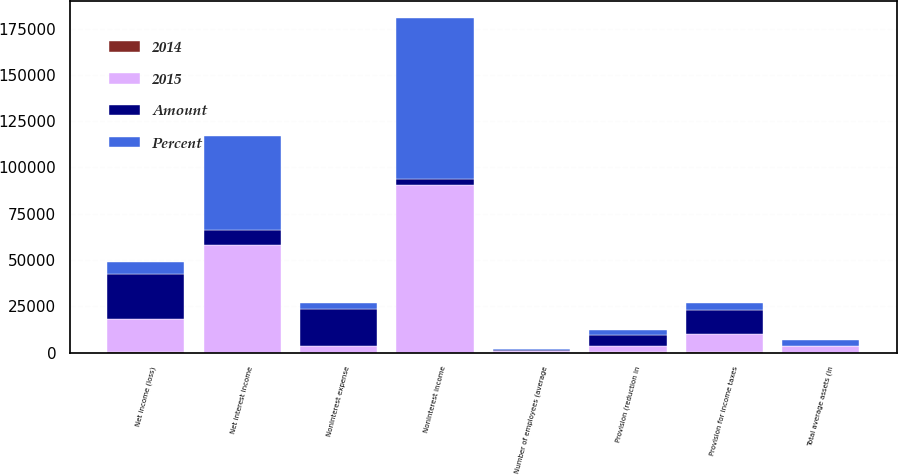Convert chart. <chart><loc_0><loc_0><loc_500><loc_500><stacked_bar_chart><ecel><fcel>Net interest income<fcel>Provision (reduction in<fcel>Noninterest income<fcel>Noninterest expense<fcel>Provision for income taxes<fcel>Net income (loss)<fcel>Number of employees (average<fcel>Total average assets (in<nl><fcel>2015<fcel>58354<fcel>3412<fcel>90358<fcel>3320<fcel>9604<fcel>17837<fcel>1071<fcel>3303<nl><fcel>Percent<fcel>50404<fcel>2671<fcel>87021<fcel>3320<fcel>3533<fcel>6561<fcel>952<fcel>3145<nl><fcel>Amount<fcel>7950<fcel>6083<fcel>3337<fcel>20165<fcel>13137<fcel>24398<fcel>119<fcel>158<nl><fcel>2014<fcel>16<fcel>228<fcel>4<fcel>14<fcel>372<fcel>372<fcel>13<fcel>5<nl></chart> 